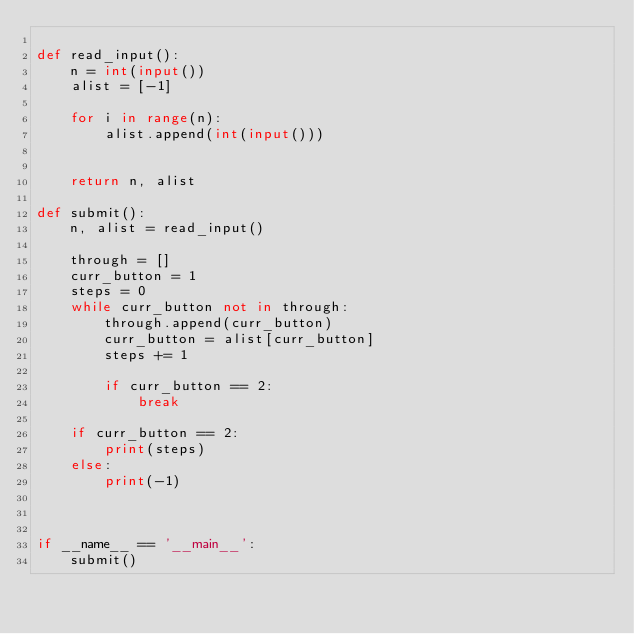Convert code to text. <code><loc_0><loc_0><loc_500><loc_500><_Python_>
def read_input():
    n = int(input())
    alist = [-1]

    for i in range(n):
        alist.append(int(input()))


    return n, alist

def submit():
    n, alist = read_input()

    through = []
    curr_button = 1
    steps = 0
    while curr_button not in through:
        through.append(curr_button)
        curr_button = alist[curr_button]
        steps += 1

        if curr_button == 2:
            break

    if curr_button == 2:
        print(steps)
    else:
        print(-1)



if __name__ == '__main__':
    submit()</code> 